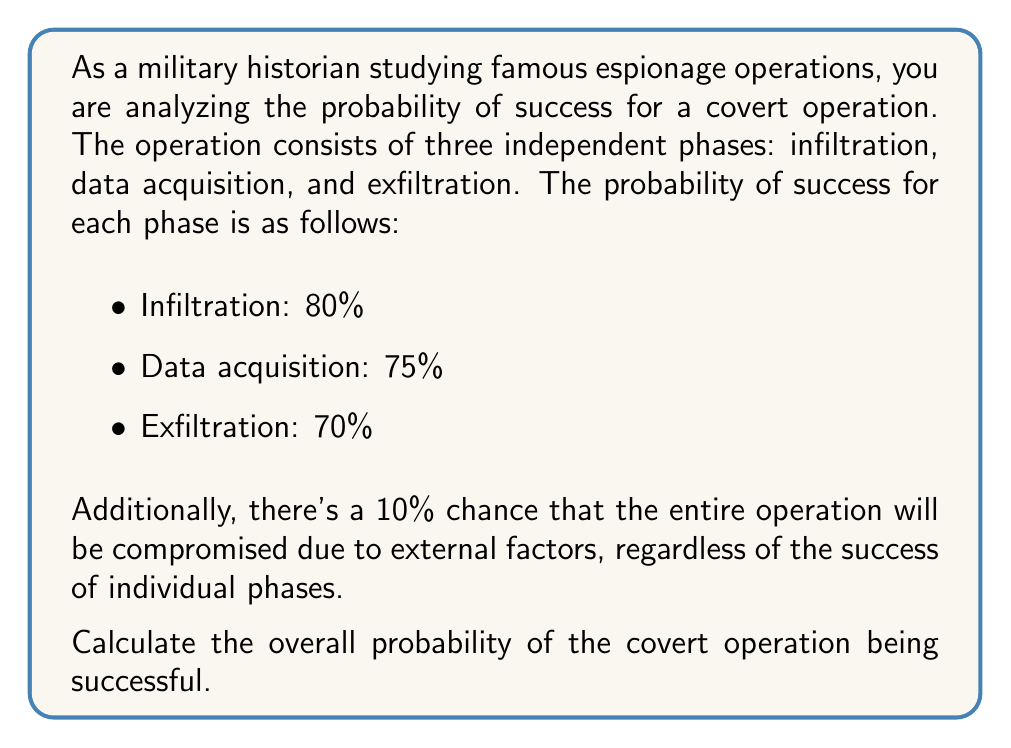Provide a solution to this math problem. To solve this problem, we'll follow these steps:

1) First, let's calculate the probability of all three phases being successful independently:

   $P(\text{all phases successful}) = 0.80 \times 0.75 \times 0.70 = 0.42$ or 42%

2) However, we also need to consider the 10% chance of the operation being compromised due to external factors. This means that even if all phases are successful, there's still a 10% chance of failure.

3) To account for this, we need to multiply the probability of all phases being successful by the probability of not being compromised due to external factors:

   $P(\text{operation successful}) = P(\text{all phases successful}) \times P(\text{not compromised})$

   $P(\text{operation successful}) = 0.42 \times (1 - 0.10) = 0.42 \times 0.90 = 0.378$

4) Therefore, the overall probability of the covert operation being successful is 0.378 or 37.8%.

This problem demonstrates the application of the multiplication rule of probability for independent events, as well as the concept of complementary events (the probability of not being compromised is 1 minus the probability of being compromised).
Answer: The overall probability of the covert operation being successful is 0.378 or 37.8%. 